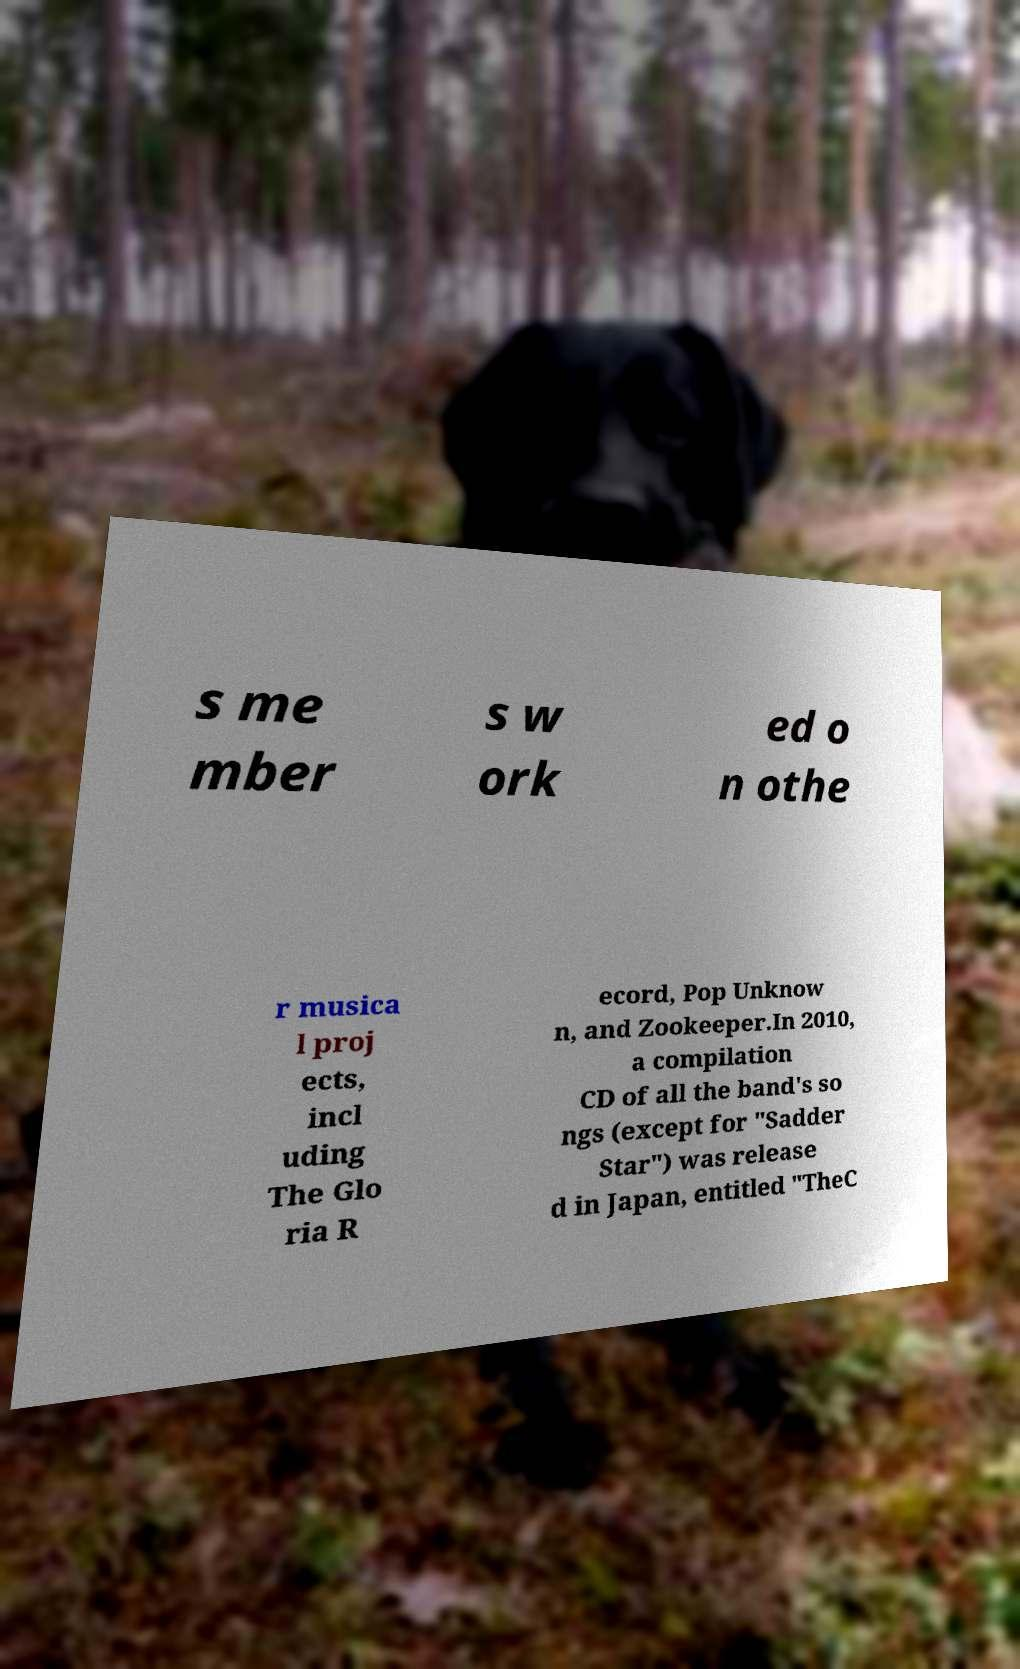I need the written content from this picture converted into text. Can you do that? s me mber s w ork ed o n othe r musica l proj ects, incl uding The Glo ria R ecord, Pop Unknow n, and Zookeeper.In 2010, a compilation CD of all the band's so ngs (except for "Sadder Star") was release d in Japan, entitled "TheC 